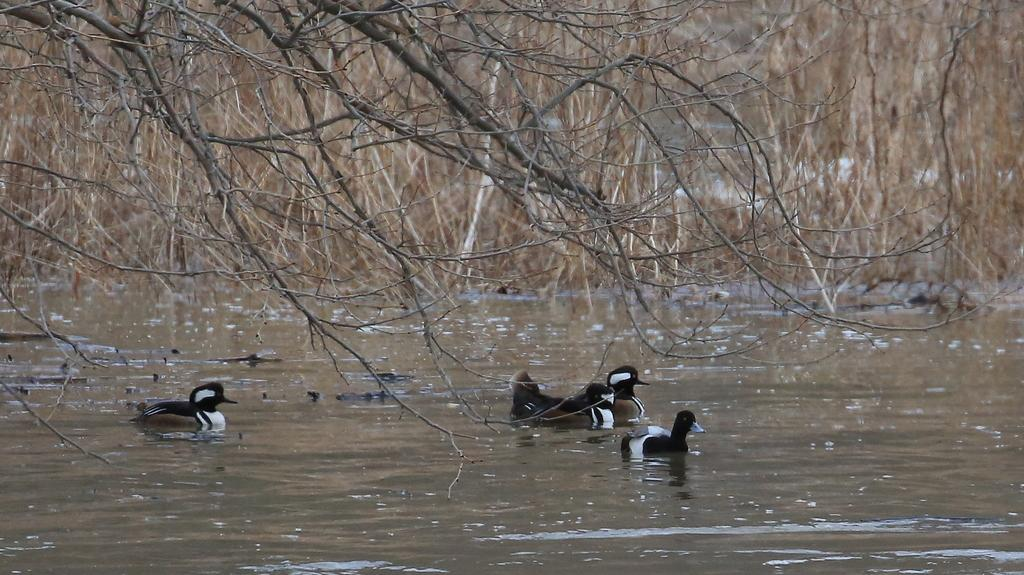What type of animals can be seen in the water in the image? There are aquatic birds in the water in the center of the image. What can be seen in the background of the image? There are trees in the background of the image. What is the condition of the tree in the front of the image? There is a dry tree in the front of the image. What type of cork can be seen floating near the aquatic birds in the image? There is no cork present in the image; it features aquatic birds in the water and trees in the background. 